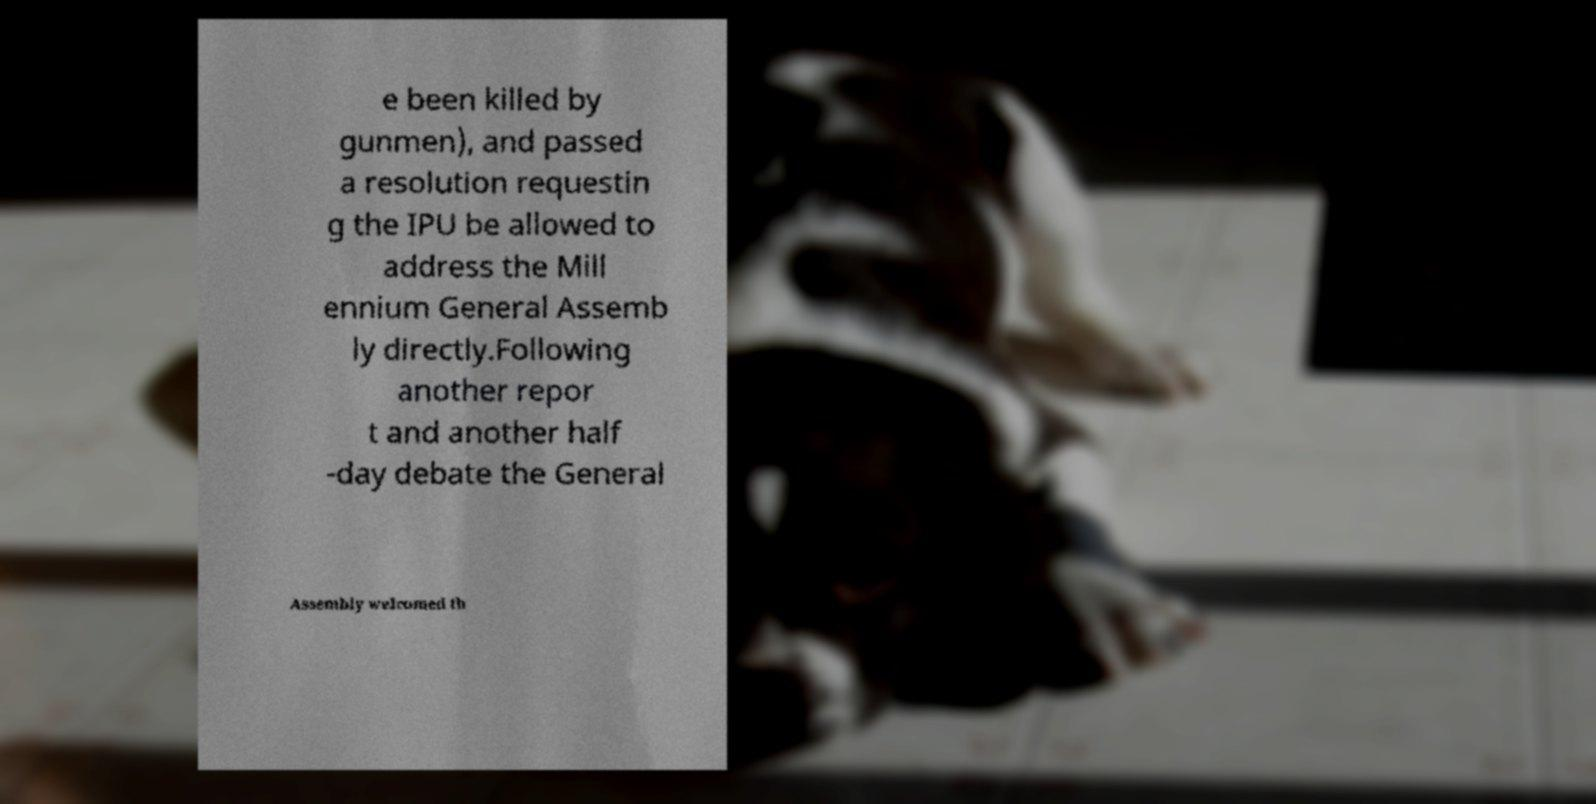Please identify and transcribe the text found in this image. e been killed by gunmen), and passed a resolution requestin g the IPU be allowed to address the Mill ennium General Assemb ly directly.Following another repor t and another half -day debate the General Assembly welcomed th 